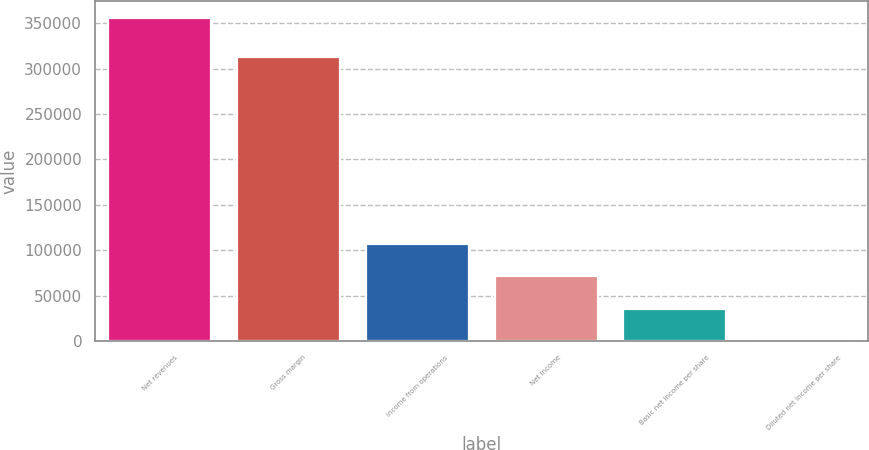Convert chart to OTSL. <chart><loc_0><loc_0><loc_500><loc_500><bar_chart><fcel>Net revenues<fcel>Gross margin<fcel>Income from operations<fcel>Net income<fcel>Basic net income per share<fcel>Diluted net income per share<nl><fcel>356155<fcel>312194<fcel>106847<fcel>71231.2<fcel>35615.7<fcel>0.26<nl></chart> 